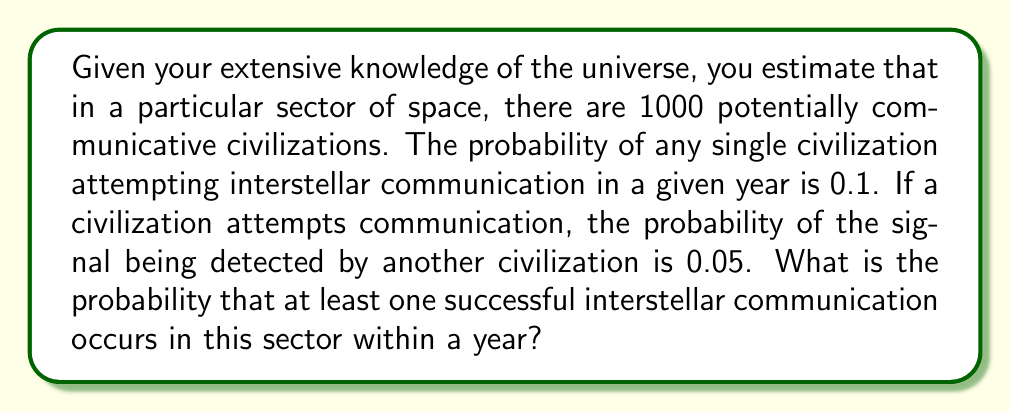Could you help me with this problem? Let's approach this step-by-step:

1) First, let's calculate the probability of a single civilization successfully communicating:
   $P(\text{success for one civilization}) = P(\text{attempt}) \times P(\text{detection})$
   $P(\text{success for one civilization}) = 0.1 \times 0.05 = 0.005$

2) Now, let's calculate the probability of a single civilization not successfully communicating:
   $P(\text{no success for one civilization}) = 1 - 0.005 = 0.995$

3) For at least one successful communication to occur, we need the opposite of no civilizations succeeding. So, we'll calculate the probability of no civilizations succeeding and then subtract from 1:

   $P(\text{at least one success}) = 1 - P(\text{no successes})$

4) The probability of no successes is the probability of all 1000 civilizations not succeeding:
   $P(\text{no successes}) = (0.995)^{1000}$

5) Therefore, the probability of at least one success is:
   $P(\text{at least one success}) = 1 - (0.995)^{1000}$

6) Calculating this:
   $P(\text{at least one success}) = 1 - (0.995)^{1000} \approx 0.9933$

Therefore, the probability of at least one successful interstellar communication occurring in this sector within a year is approximately 0.9933 or 99.33%.
Answer: $1 - (0.995)^{1000} \approx 0.9933$ 